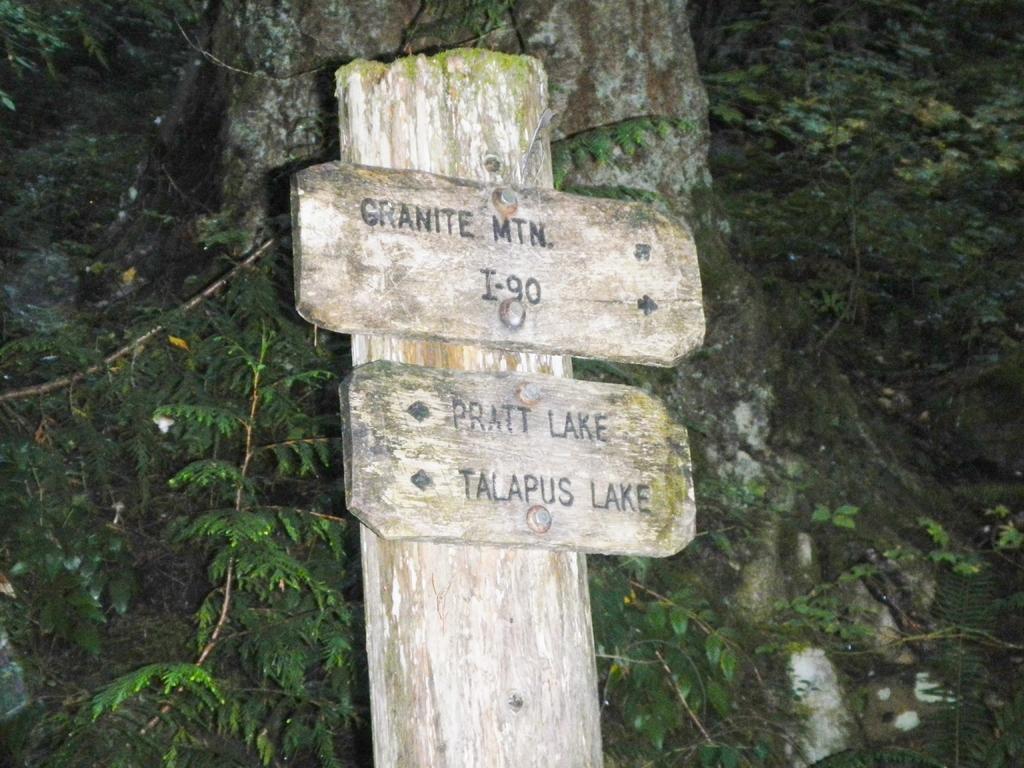Please provide a concise description of this image. In this image I can see a board with some text written on it. In the background, I can see the plants. 